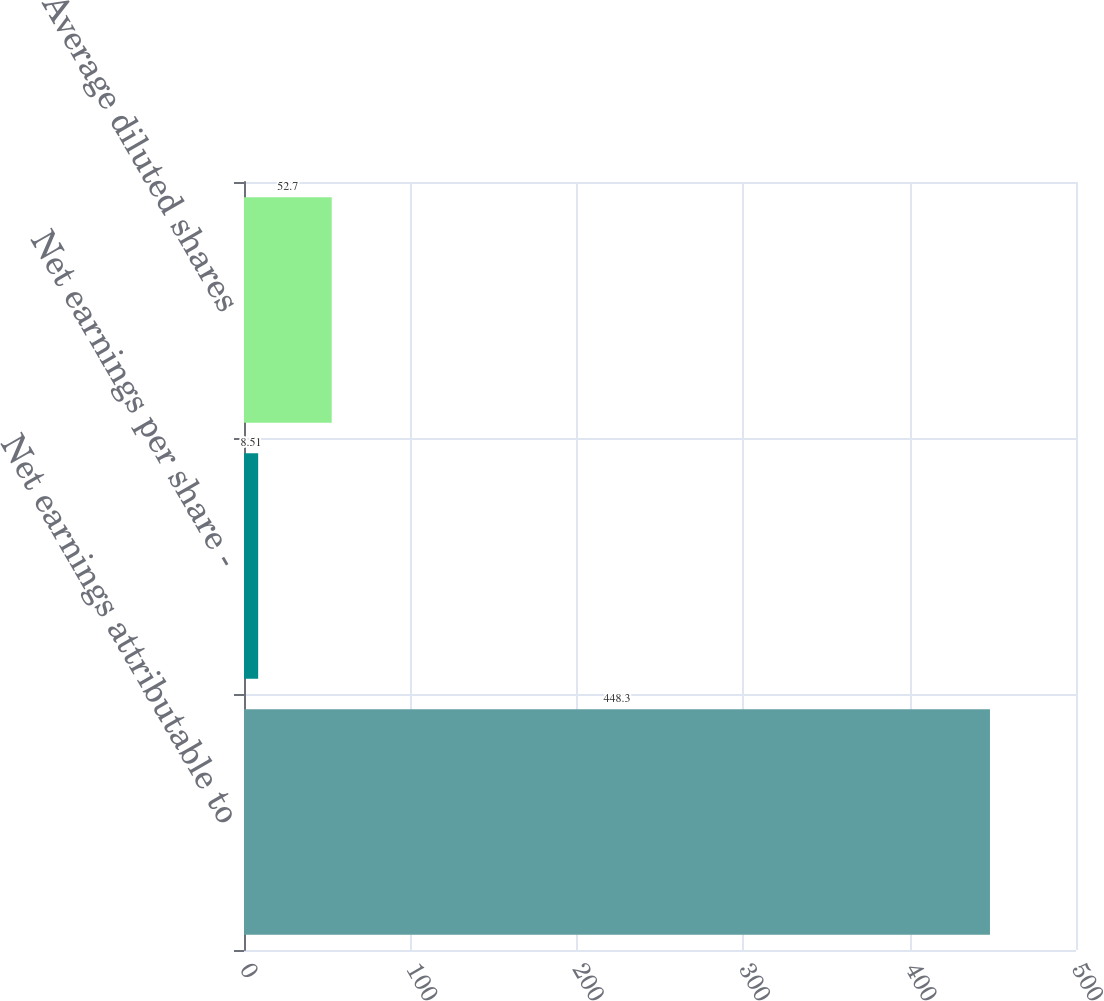Convert chart. <chart><loc_0><loc_0><loc_500><loc_500><bar_chart><fcel>Net earnings attributable to<fcel>Net earnings per share -<fcel>Average diluted shares<nl><fcel>448.3<fcel>8.51<fcel>52.7<nl></chart> 